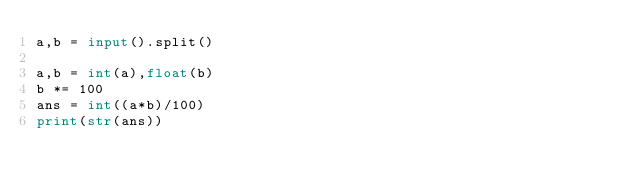Convert code to text. <code><loc_0><loc_0><loc_500><loc_500><_Python_>a,b = input().split()

a,b = int(a),float(b)
b *= 100
ans = int((a*b)/100)
print(str(ans))</code> 